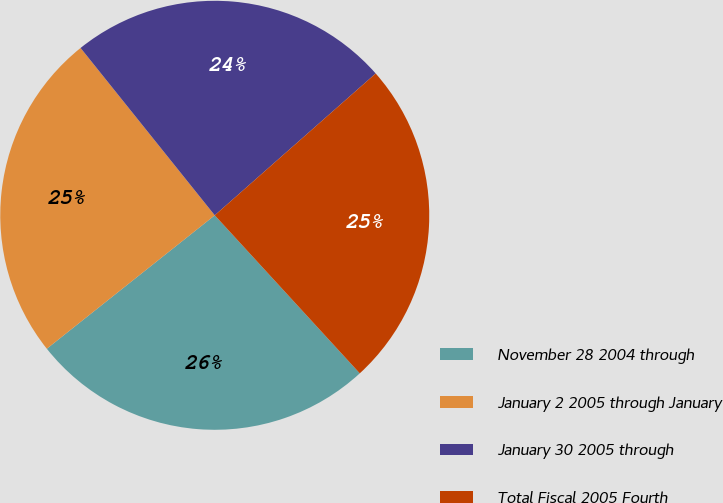<chart> <loc_0><loc_0><loc_500><loc_500><pie_chart><fcel>November 28 2004 through<fcel>January 2 2005 through January<fcel>January 30 2005 through<fcel>Total Fiscal 2005 Fourth<nl><fcel>26.13%<fcel>24.93%<fcel>24.26%<fcel>24.68%<nl></chart> 